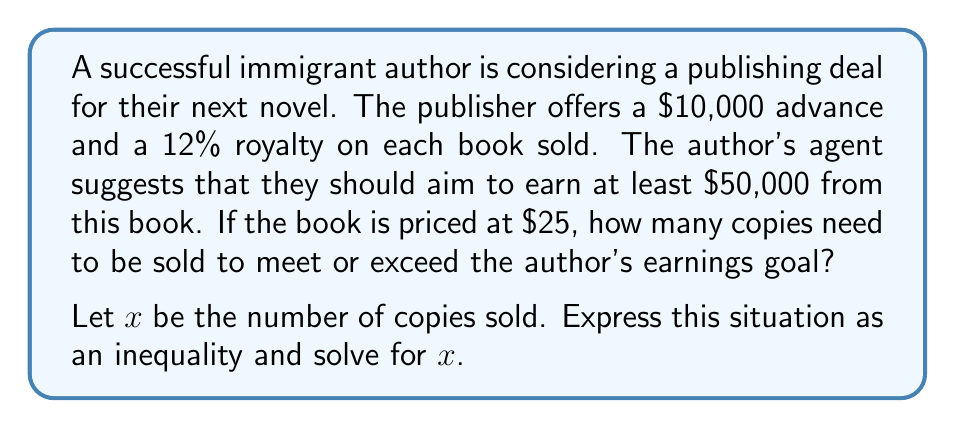Teach me how to tackle this problem. Let's approach this step-by-step:

1) First, let's set up the inequality:
   Advance + (Royalty per book × Number of books) ≥ Earnings goal
   
   $10000 + (0.12 \times 25 \times x) \geq 50000$

2) Simplify the left side of the inequality:
   $10000 + 3x \geq 50000$

3) Subtract 10000 from both sides:
   $3x \geq 40000$

4) Divide both sides by 3:
   $x \geq \frac{40000}{3}$

5) Simplify:
   $x \geq 13333.33$

6) Since we're dealing with whole books, we need to round up to the nearest whole number:
   $x \geq 13334$

Therefore, the author needs to sell at least 13,334 copies to meet or exceed their earnings goal.
Answer: $x \geq 13334$ 